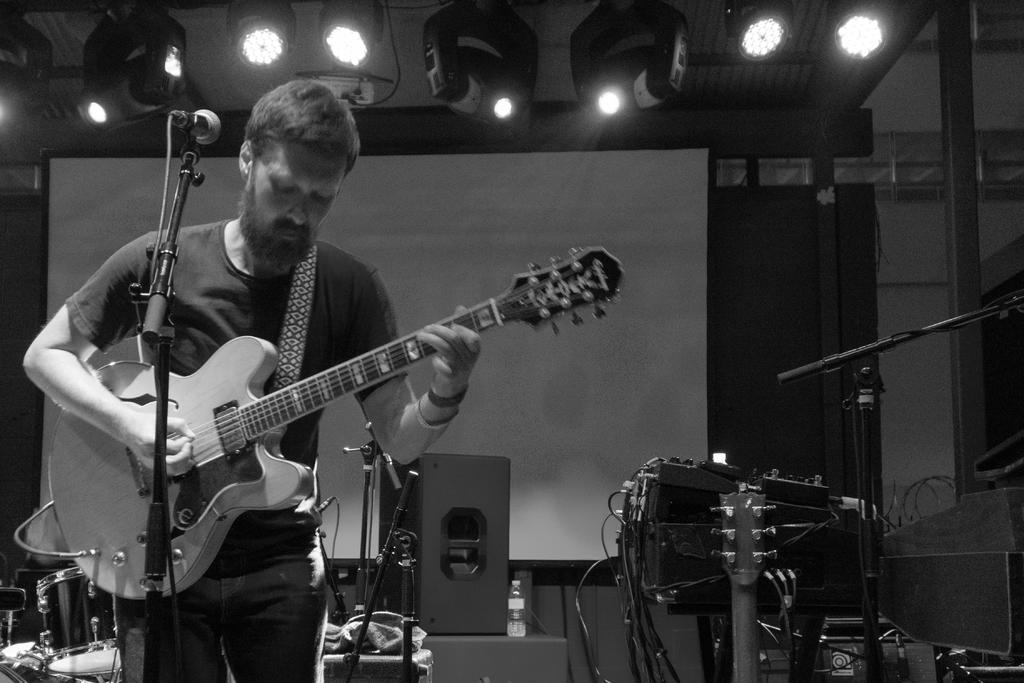What is the man in the image holding? The man is holding a guitar. What can be seen at the top of the image? There are lights at the top of the image. How does the man in the image say good-bye to the audience? There is no indication in the image that the man is saying good-bye to an audience, as the focus is on him holding a guitar. 